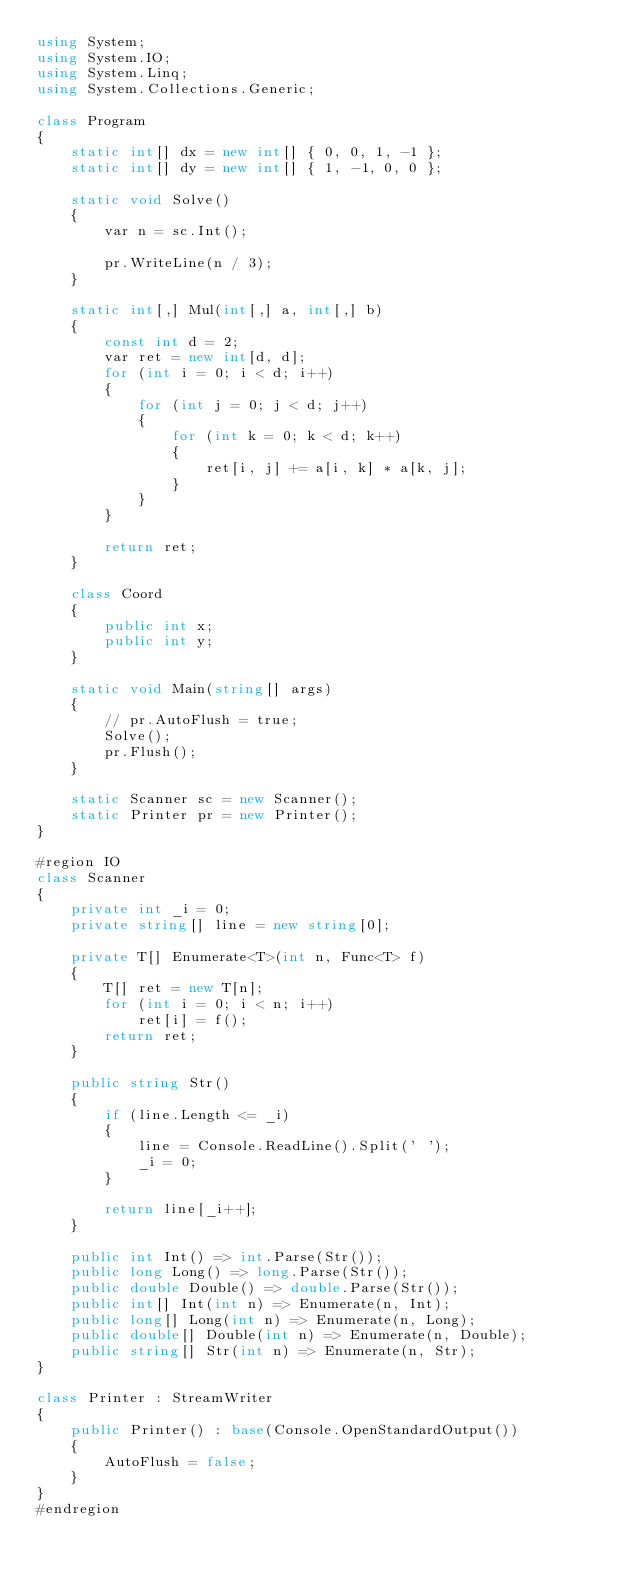Convert code to text. <code><loc_0><loc_0><loc_500><loc_500><_C#_>using System;
using System.IO;
using System.Linq;
using System.Collections.Generic;

class Program
{
    static int[] dx = new int[] { 0, 0, 1, -1 };
    static int[] dy = new int[] { 1, -1, 0, 0 };

    static void Solve()
    {
        var n = sc.Int();

        pr.WriteLine(n / 3);
    }

    static int[,] Mul(int[,] a, int[,] b)
    {
        const int d = 2;
        var ret = new int[d, d];
        for (int i = 0; i < d; i++)
        {
            for (int j = 0; j < d; j++)
            {
                for (int k = 0; k < d; k++)
                {
                    ret[i, j] += a[i, k] * a[k, j];
                }
            }
        }

        return ret;
    }

    class Coord
    {
        public int x;
        public int y;
    }

    static void Main(string[] args)
    {
        // pr.AutoFlush = true;
        Solve();
        pr.Flush();
    }

    static Scanner sc = new Scanner();
    static Printer pr = new Printer();
}

#region IO
class Scanner
{
    private int _i = 0;
    private string[] line = new string[0];

    private T[] Enumerate<T>(int n, Func<T> f)
    {
        T[] ret = new T[n];
        for (int i = 0; i < n; i++)
            ret[i] = f();
        return ret;
    }

    public string Str()
    {
        if (line.Length <= _i)
        {
            line = Console.ReadLine().Split(' ');
            _i = 0;
        }

        return line[_i++];
    }

    public int Int() => int.Parse(Str());
    public long Long() => long.Parse(Str());
    public double Double() => double.Parse(Str());
    public int[] Int(int n) => Enumerate(n, Int);
    public long[] Long(int n) => Enumerate(n, Long);
    public double[] Double(int n) => Enumerate(n, Double);
    public string[] Str(int n) => Enumerate(n, Str);
}

class Printer : StreamWriter
{
    public Printer() : base(Console.OpenStandardOutput())
    {
        AutoFlush = false;
    }
}
#endregion</code> 